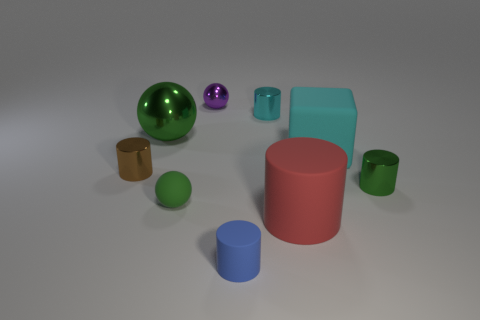Is there a rubber sphere of the same color as the rubber block?
Provide a succinct answer. No. There is a metallic cylinder that is left of the green matte object; is it the same size as the green cylinder?
Provide a succinct answer. Yes. Is the number of green balls less than the number of green objects?
Your response must be concise. Yes. Are there any brown cubes that have the same material as the brown object?
Provide a succinct answer. No. There is a tiny purple metal object right of the tiny brown metal cylinder; what is its shape?
Offer a terse response. Sphere. Do the large thing that is in front of the rubber cube and the large cube have the same color?
Provide a succinct answer. No. Is the number of small shiny cylinders that are left of the tiny blue thing less than the number of matte spheres?
Your answer should be compact. No. What color is the large cylinder that is made of the same material as the tiny blue cylinder?
Your answer should be very brief. Red. What size is the cylinder that is left of the blue matte cylinder?
Offer a very short reply. Small. Does the small cyan cylinder have the same material as the tiny green cylinder?
Provide a short and direct response. Yes. 